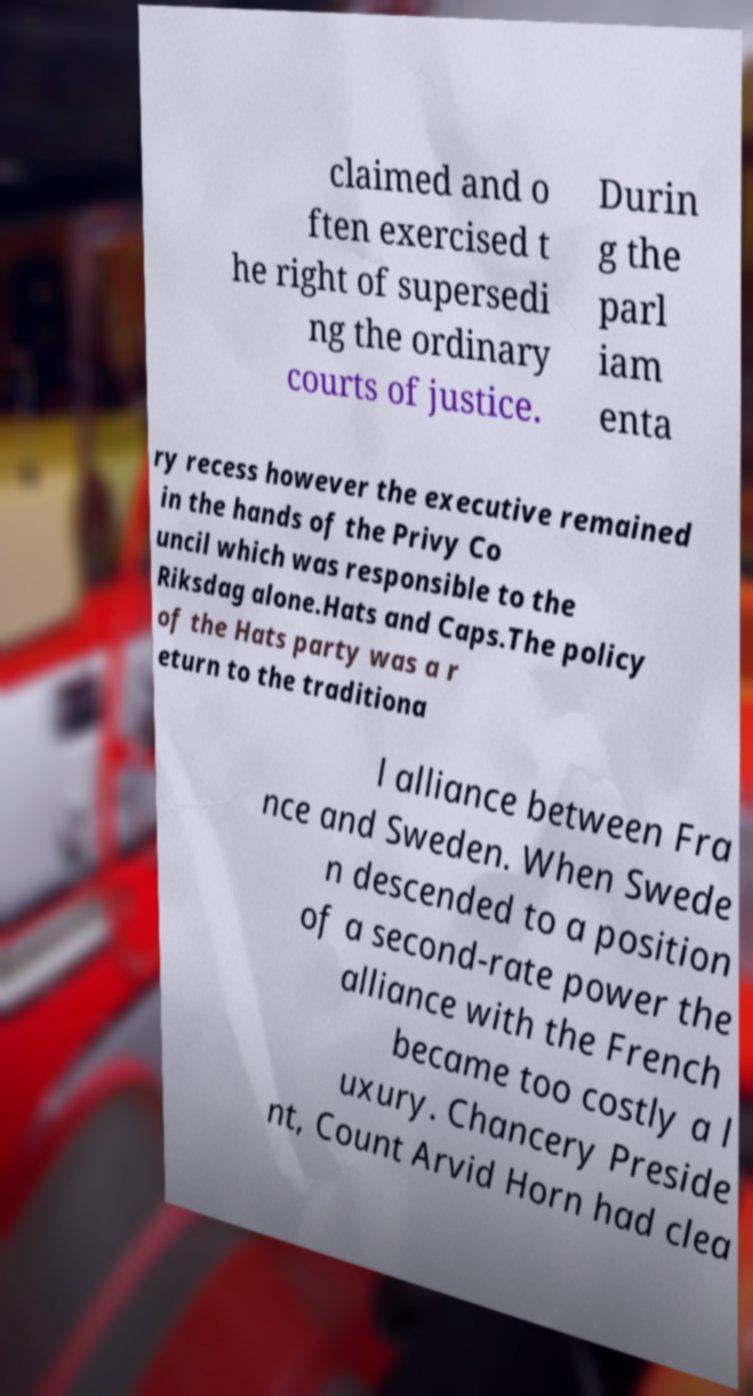What messages or text are displayed in this image? I need them in a readable, typed format. claimed and o ften exercised t he right of supersedi ng the ordinary courts of justice. Durin g the parl iam enta ry recess however the executive remained in the hands of the Privy Co uncil which was responsible to the Riksdag alone.Hats and Caps.The policy of the Hats party was a r eturn to the traditiona l alliance between Fra nce and Sweden. When Swede n descended to a position of a second-rate power the alliance with the French became too costly a l uxury. Chancery Preside nt, Count Arvid Horn had clea 